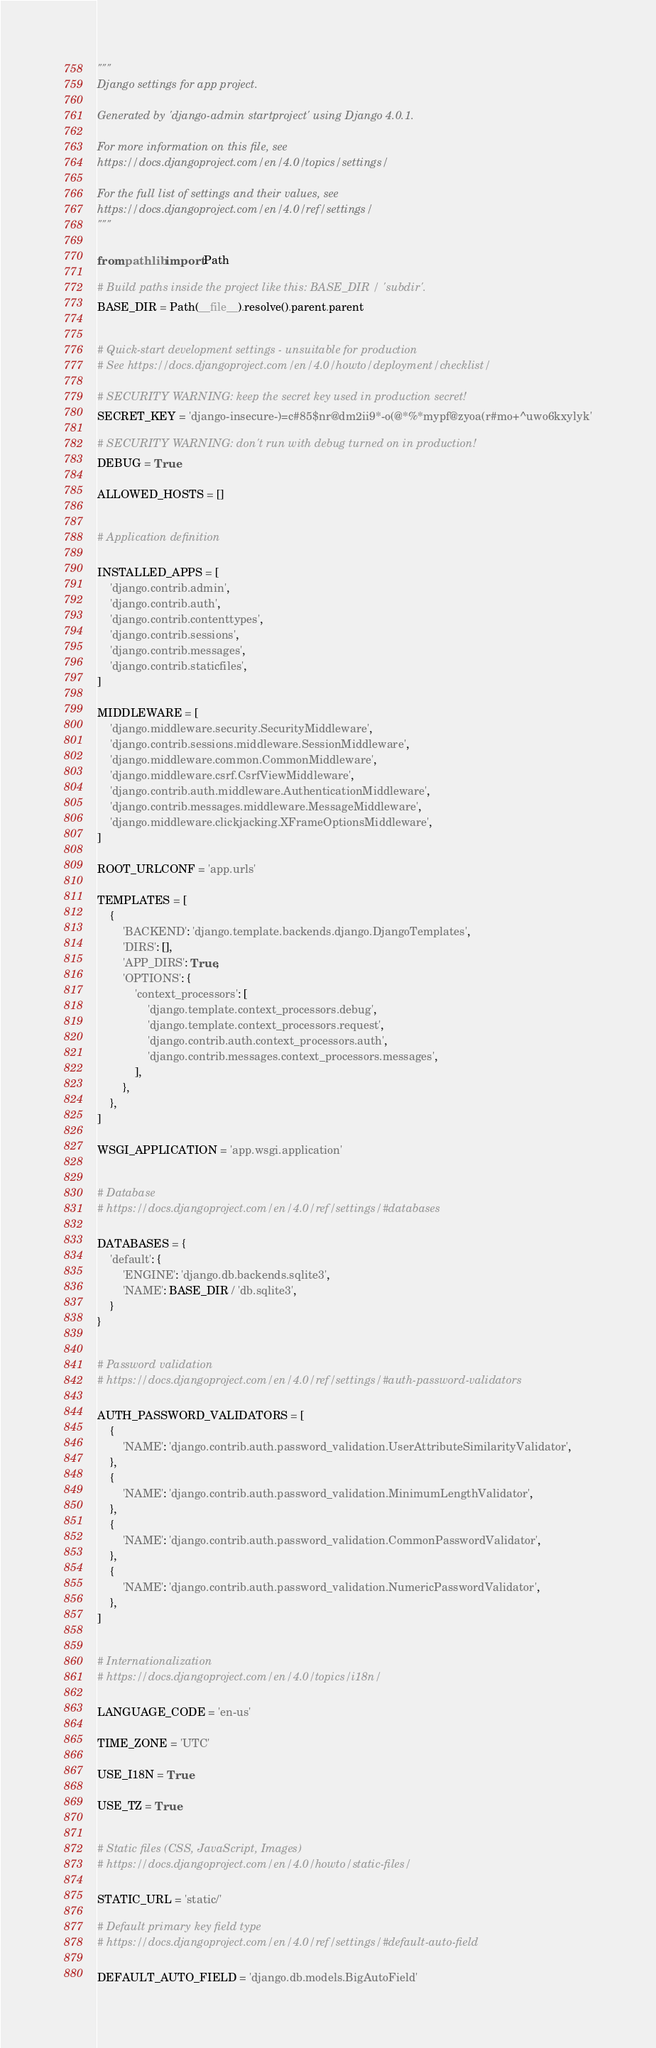<code> <loc_0><loc_0><loc_500><loc_500><_Python_>"""
Django settings for app project.

Generated by 'django-admin startproject' using Django 4.0.1.

For more information on this file, see
https://docs.djangoproject.com/en/4.0/topics/settings/

For the full list of settings and their values, see
https://docs.djangoproject.com/en/4.0/ref/settings/
"""

from pathlib import Path

# Build paths inside the project like this: BASE_DIR / 'subdir'.
BASE_DIR = Path(__file__).resolve().parent.parent


# Quick-start development settings - unsuitable for production
# See https://docs.djangoproject.com/en/4.0/howto/deployment/checklist/

# SECURITY WARNING: keep the secret key used in production secret!
SECRET_KEY = 'django-insecure-)=c#85$nr@dm2ii9*-o(@*%*mypf@zyoa(r#mo+^uwo6kxylyk'

# SECURITY WARNING: don't run with debug turned on in production!
DEBUG = True

ALLOWED_HOSTS = []


# Application definition

INSTALLED_APPS = [
    'django.contrib.admin',
    'django.contrib.auth',
    'django.contrib.contenttypes',
    'django.contrib.sessions',
    'django.contrib.messages',
    'django.contrib.staticfiles',
]

MIDDLEWARE = [
    'django.middleware.security.SecurityMiddleware',
    'django.contrib.sessions.middleware.SessionMiddleware',
    'django.middleware.common.CommonMiddleware',
    'django.middleware.csrf.CsrfViewMiddleware',
    'django.contrib.auth.middleware.AuthenticationMiddleware',
    'django.contrib.messages.middleware.MessageMiddleware',
    'django.middleware.clickjacking.XFrameOptionsMiddleware',
]

ROOT_URLCONF = 'app.urls'

TEMPLATES = [
    {
        'BACKEND': 'django.template.backends.django.DjangoTemplates',
        'DIRS': [],
        'APP_DIRS': True,
        'OPTIONS': {
            'context_processors': [
                'django.template.context_processors.debug',
                'django.template.context_processors.request',
                'django.contrib.auth.context_processors.auth',
                'django.contrib.messages.context_processors.messages',
            ],
        },
    },
]

WSGI_APPLICATION = 'app.wsgi.application'


# Database
# https://docs.djangoproject.com/en/4.0/ref/settings/#databases

DATABASES = {
    'default': {
        'ENGINE': 'django.db.backends.sqlite3',
        'NAME': BASE_DIR / 'db.sqlite3',
    }
}


# Password validation
# https://docs.djangoproject.com/en/4.0/ref/settings/#auth-password-validators

AUTH_PASSWORD_VALIDATORS = [
    {
        'NAME': 'django.contrib.auth.password_validation.UserAttributeSimilarityValidator',
    },
    {
        'NAME': 'django.contrib.auth.password_validation.MinimumLengthValidator',
    },
    {
        'NAME': 'django.contrib.auth.password_validation.CommonPasswordValidator',
    },
    {
        'NAME': 'django.contrib.auth.password_validation.NumericPasswordValidator',
    },
]


# Internationalization
# https://docs.djangoproject.com/en/4.0/topics/i18n/

LANGUAGE_CODE = 'en-us'

TIME_ZONE = 'UTC'

USE_I18N = True

USE_TZ = True


# Static files (CSS, JavaScript, Images)
# https://docs.djangoproject.com/en/4.0/howto/static-files/

STATIC_URL = 'static/'

# Default primary key field type
# https://docs.djangoproject.com/en/4.0/ref/settings/#default-auto-field

DEFAULT_AUTO_FIELD = 'django.db.models.BigAutoField'
</code> 